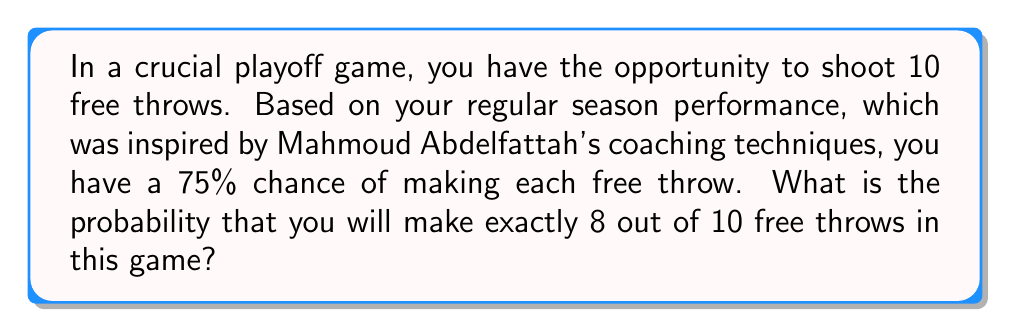Could you help me with this problem? To solve this problem, we'll use the binomial distribution, which is appropriate for a fixed number of independent trials with two possible outcomes (success or failure) and a constant probability of success.

Let's define our variables:
$n = 10$ (number of free throws)
$k = 8$ (number of successful free throws we're interested in)
$p = 0.75$ (probability of making a single free throw)
$q = 1 - p = 0.25$ (probability of missing a single free throw)

The probability mass function for the binomial distribution is:

$$P(X = k) = \binom{n}{k} p^k q^{n-k}$$

Where $\binom{n}{k}$ is the binomial coefficient, calculated as:

$$\binom{n}{k} = \frac{n!}{k!(n-k)!}$$

Step 1: Calculate the binomial coefficient
$$\binom{10}{8} = \frac{10!}{8!(10-8)!} = \frac{10!}{8!2!} = 45$$

Step 2: Plug all values into the binomial probability mass function
$$P(X = 8) = 45 \cdot (0.75)^8 \cdot (0.25)^{10-8}$$

Step 3: Simplify and calculate
$$P(X = 8) = 45 \cdot (0.75)^8 \cdot (0.25)^2$$
$$P(X = 8) = 45 \cdot 0.1001129150390625 \cdot 0.0625$$
$$P(X = 8) = 0.2815990447998047$$

Therefore, the probability of making exactly 8 out of 10 free throws is approximately 0.2816 or 28.16%.
Answer: 0.2816 